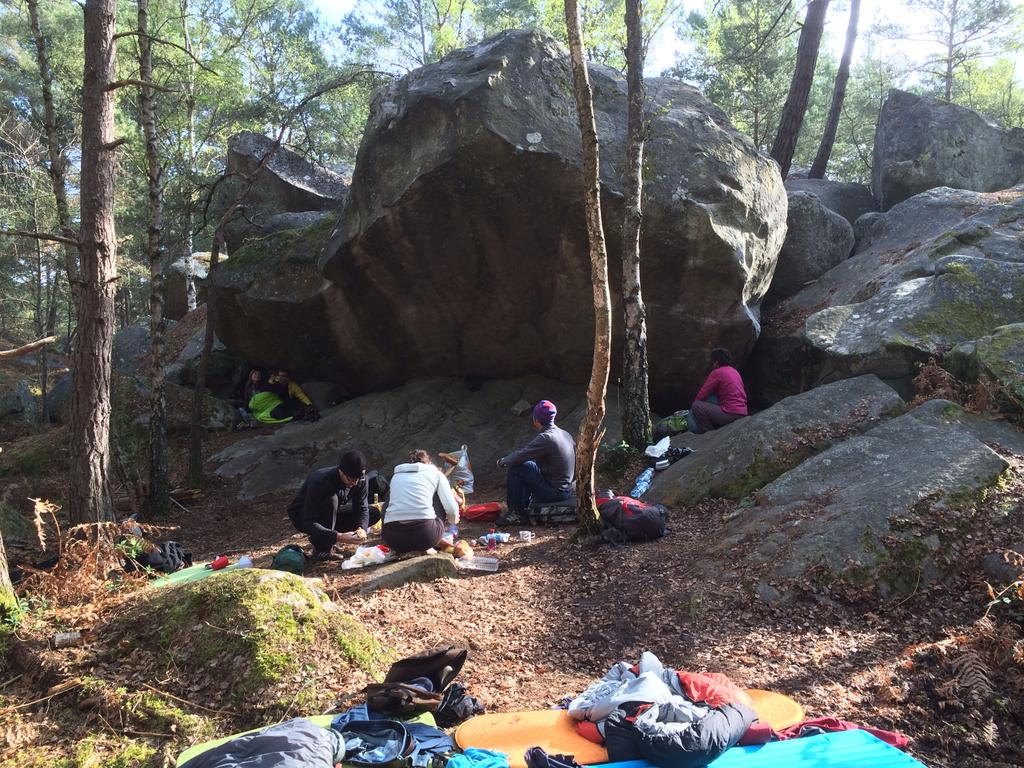Who or what is present in the image? There are people in the image. What type of natural elements can be seen in the image? There are rocks and trees in the image. What items might the people be carrying or using in the image? There are bags in the image. Can you describe any other objects or features in the image? There are other unspecified objects in the image. What type of jar is visible in the image? There is no jar present in the image. Can you describe the bone that is being held by one of the people in the image? There is no bone present in the image. 